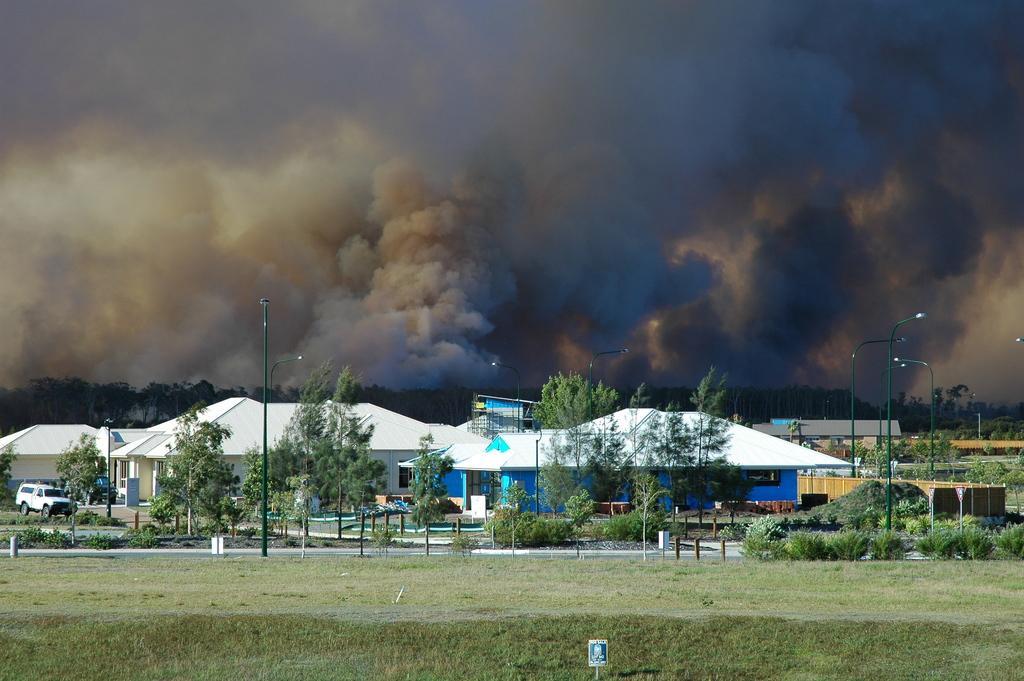Could you give a brief overview of what you see in this image? In the foreground, I can see grass, light poles, plants, trees, vehicles on the road and houses. In the background, I can see smoke and the sky. This image is taken in a day. 